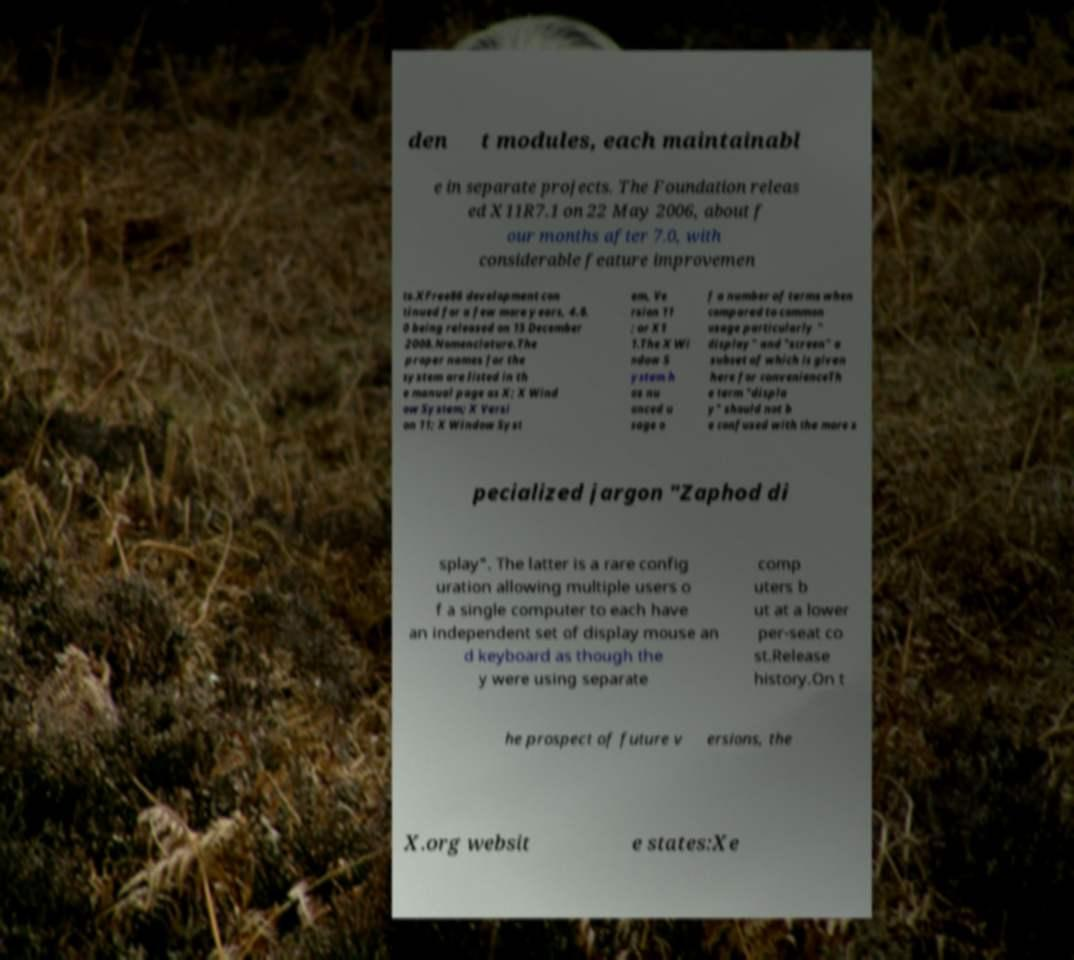I need the written content from this picture converted into text. Can you do that? den t modules, each maintainabl e in separate projects. The Foundation releas ed X11R7.1 on 22 May 2006, about f our months after 7.0, with considerable feature improvemen ts.XFree86 development con tinued for a few more years, 4.8. 0 being released on 15 December 2008.Nomenclature.The proper names for the system are listed in th e manual page as X; X Wind ow System; X Versi on 11; X Window Syst em, Ve rsion 11 ; or X1 1.The X Wi ndow S ystem h as nu anced u sage o f a number of terms when compared to common usage particularly " display" and "screen" a subset of which is given here for convenienceTh e term "displa y" should not b e confused with the more s pecialized jargon "Zaphod di splay". The latter is a rare config uration allowing multiple users o f a single computer to each have an independent set of display mouse an d keyboard as though the y were using separate comp uters b ut at a lower per-seat co st.Release history.On t he prospect of future v ersions, the X.org websit e states:Xe 